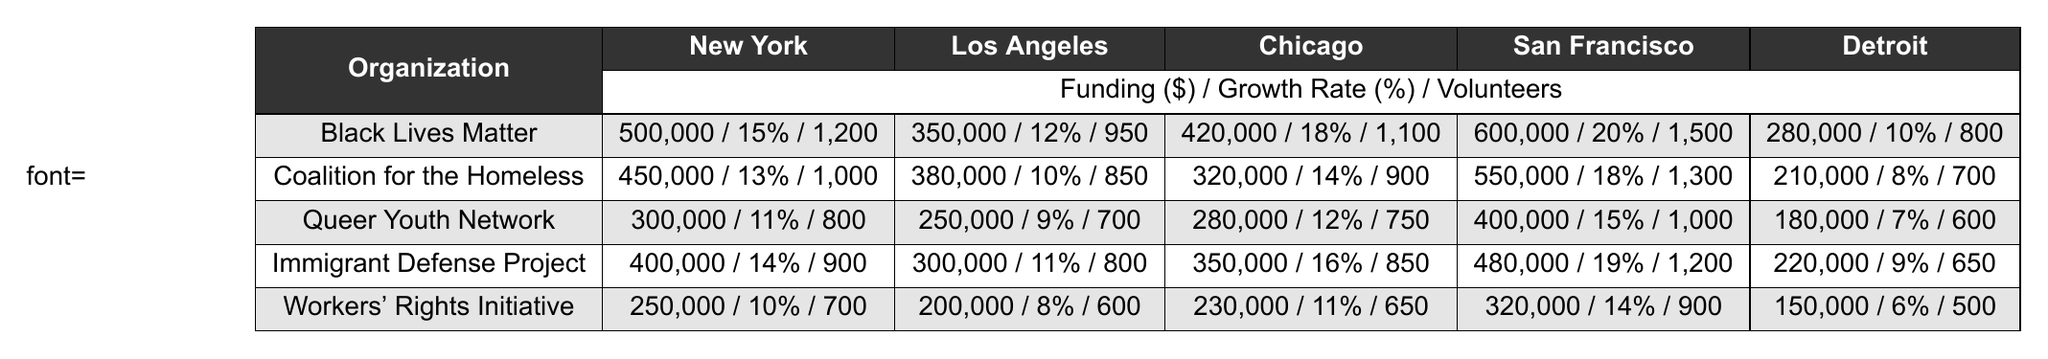What is the funding amount for Black Lives Matter in New York? The table shows that Black Lives Matter received a funding amount of 500,000 in New York.
Answer: 500,000 Which organization received the highest funding in San Francisco? In San Francisco, Black Lives Matter received the highest funding amount of 600,000.
Answer: Black Lives Matter What is the average funding received by Coalition for the Homeless across all cities? The funding amounts for Coalition for the Homeless are 450,000, 380,000, 320,000, 550,000, and 210,000. Summing these up gives 1,910,000, and dividing by 5 (the number of cities) results in an average of 382,000.
Answer: 382,000 Did any organization receive more than 300,000 in funding in Detroit? Yes, the funding amounts in Detroit are 280,000 (Black Lives Matter), 210,000 (Coalition for the Homeless), 180,000 (Queer Youth Network), 220,000 (Immigrant Defense Project), and 150,000 (Workers' Rights Initiative). None of these amounts exceed 300,000.
Answer: No Which city has the highest growth rate for the Immigrant Defense Project? The growth rates for Immigrant Defense Project across cities are 0.14 (New York), 0.11 (Los Angeles), 0.16 (Chicago), 0.19 (San Francisco), and 0.09 (Detroit). The highest growth rate is 0.19 in San Francisco.
Answer: San Francisco How much more funding did the Queer Youth Network receive in Chicago compared to Detroit? The funding for Queer Youth Network in Chicago is 280,000, and in Detroit, it is 180,000. The difference is 280,000 - 180,000 = 100,000.
Answer: 100,000 What is the total volunteer count for Workers' Rights Initiative across all cities? The volunteer counts for Workers' Rights Initiative are 700 (New York), 600 (Los Angeles), 650 (Chicago), 900 (San Francisco), and 500 (Detroit). Summing these gives 700 + 600 + 650 + 900 + 500 = 3360.
Answer: 3360 Which organization has the lowest volunteer count in all cities? Upon reviewing the volunteer counts, Workers' Rights Initiative has the lowest count of 500 in Detroit.
Answer: Workers' Rights Initiative Is there an organization that has a growth rate lower than 0.10 in any city? Analyzing the growth rates, Workers' Rights Initiative has a growth rate of 0.08 in Los Angeles and 0.06 in Detroit, both less than 0.10.
Answer: Yes Which organization received the least funding in New York, and what is the amount? In New York, the funding amounts are 500,000 (Black Lives Matter), 450,000 (Coalition for the Homeless), 300,000 (Queer Youth Network), 400,000 (Immigrant Defense Project), and 250,000 (Workers' Rights Initiative). The least is 250,000 for Workers' Rights Initiative.
Answer: Workers' Rights Initiative, 250,000 